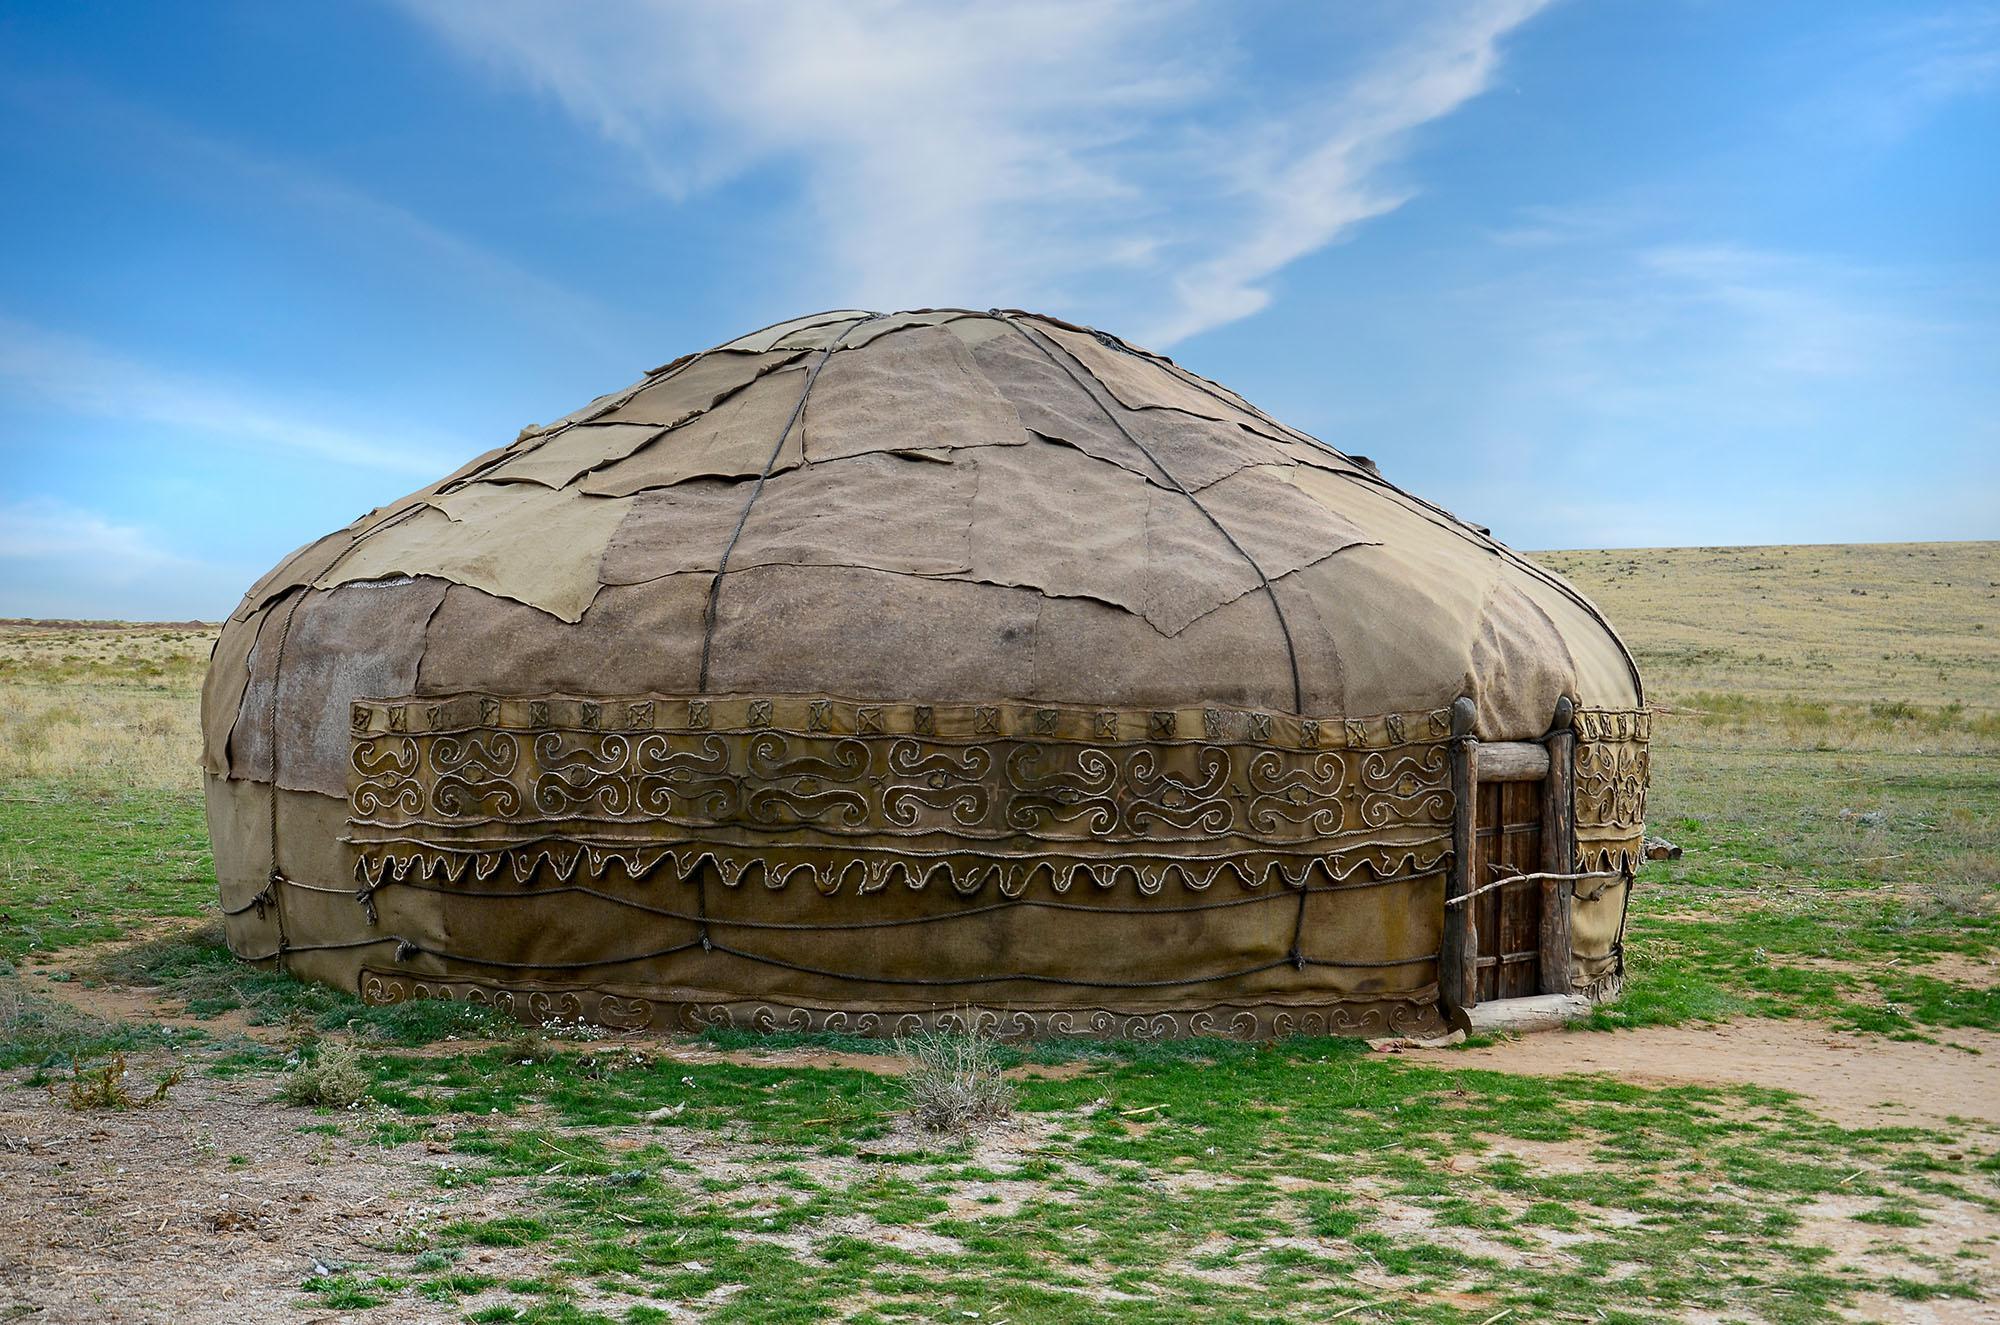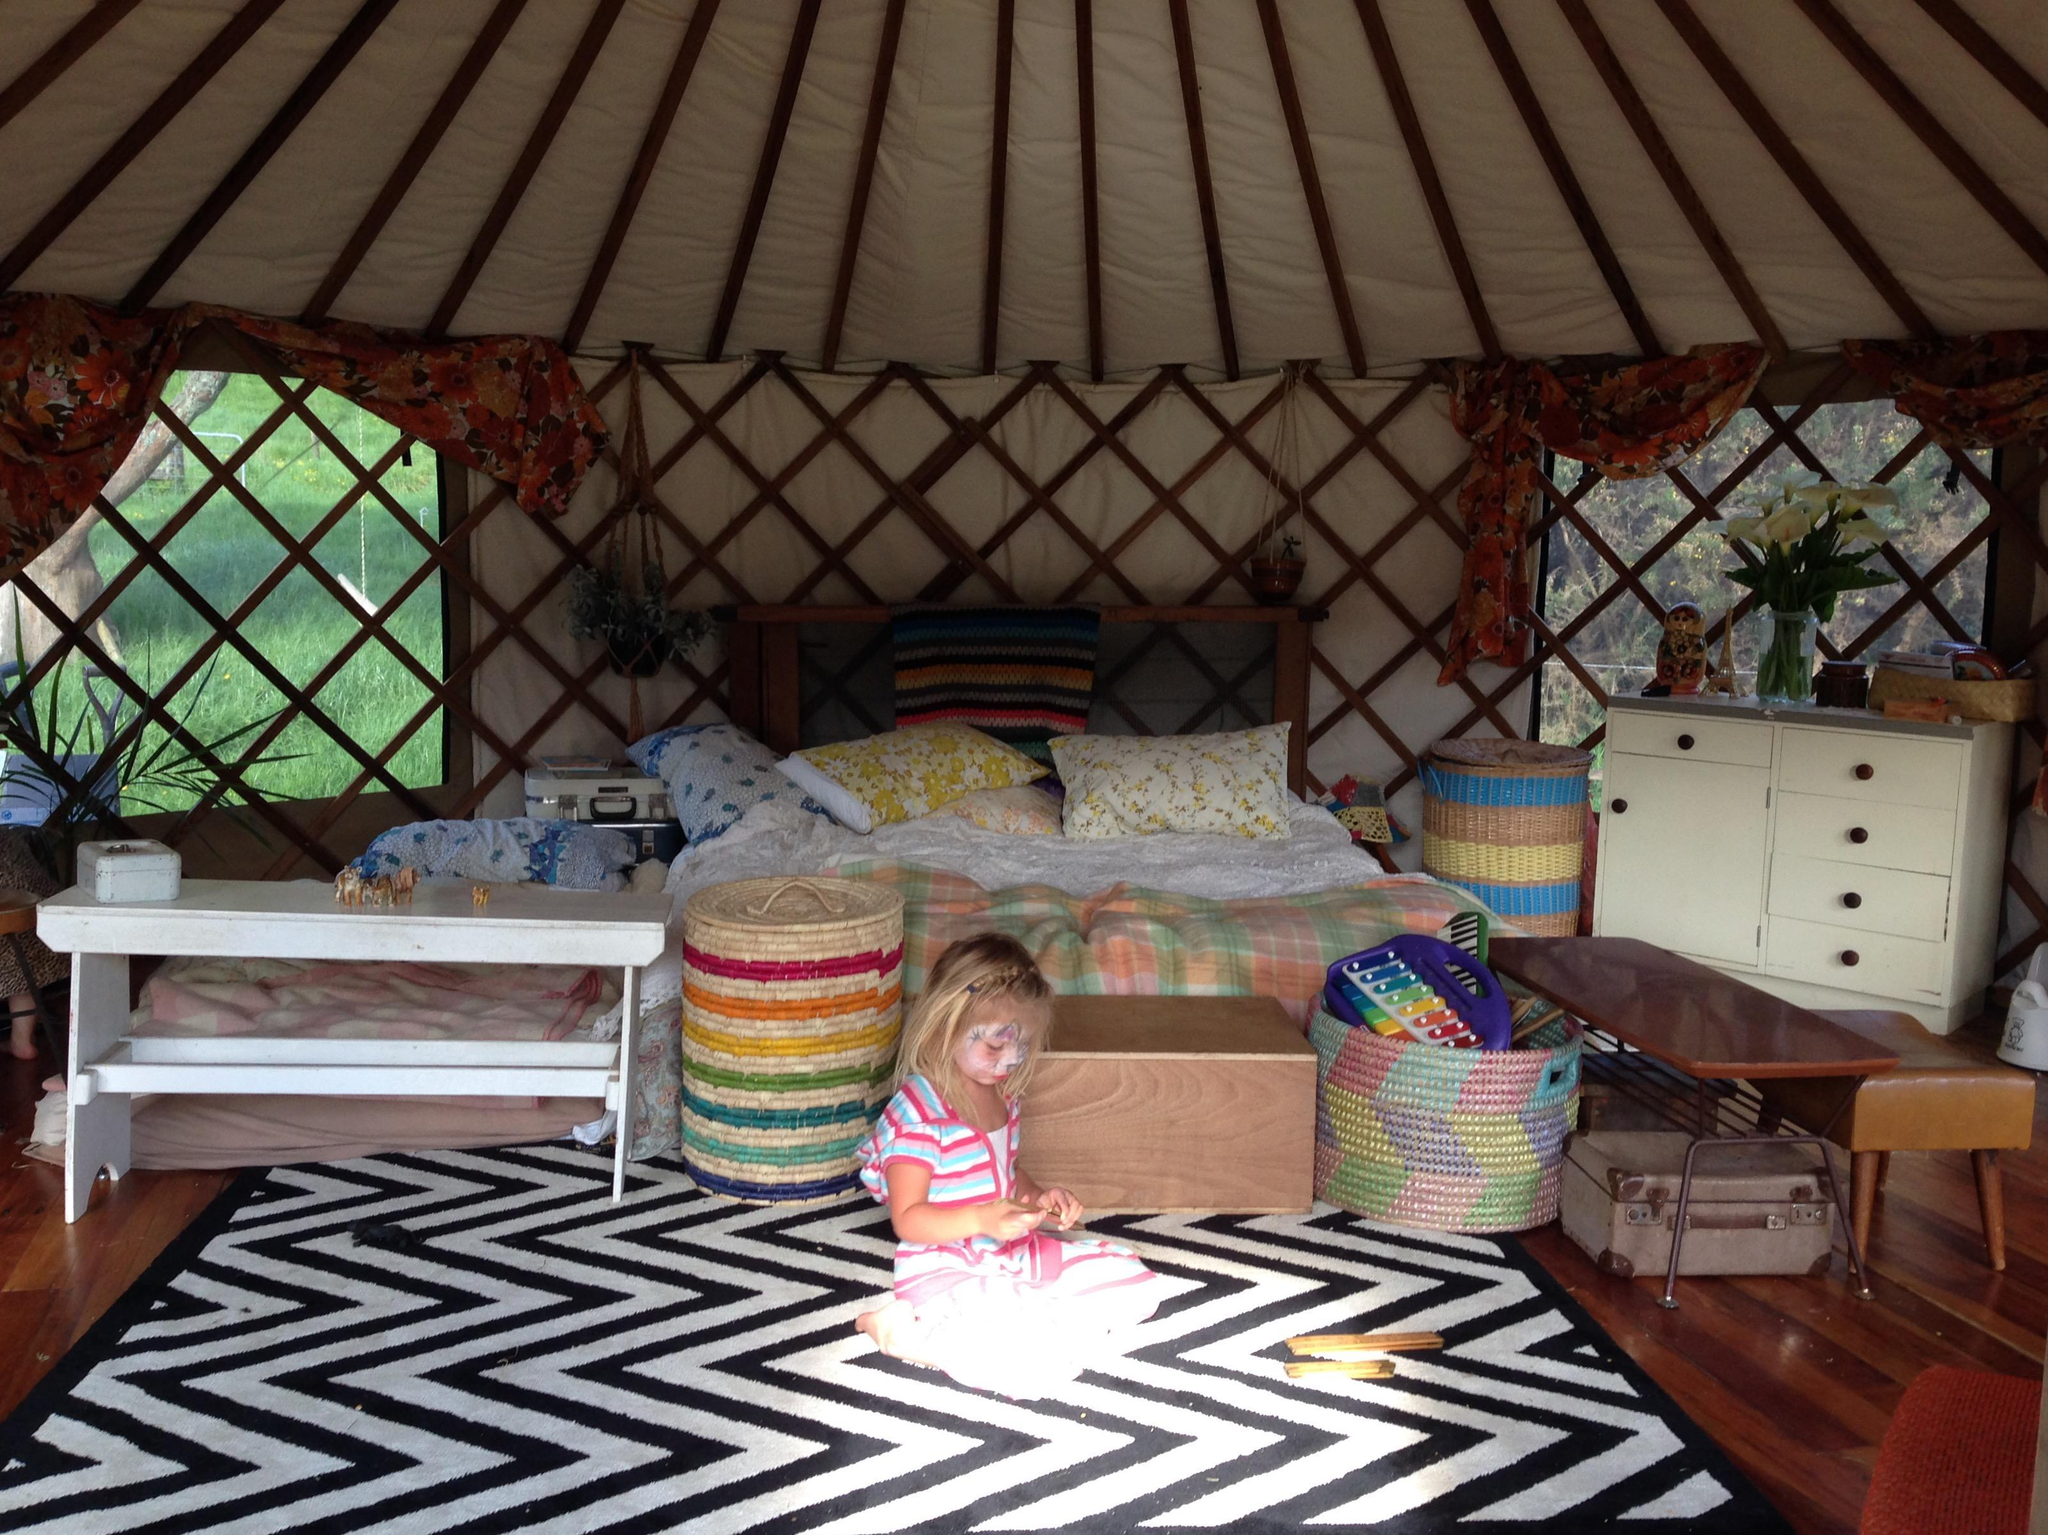The first image is the image on the left, the second image is the image on the right. Examine the images to the left and right. Is the description "there is exactly one person in the image on the right." accurate? Answer yes or no. Yes. 